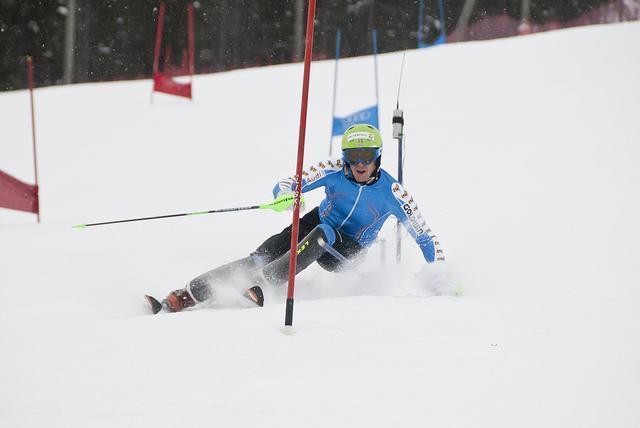How many people have remotes in their hands?
Give a very brief answer. 0. 